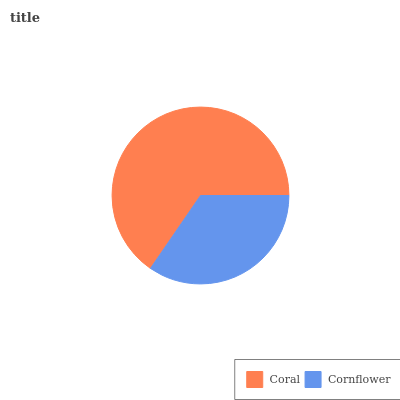Is Cornflower the minimum?
Answer yes or no. Yes. Is Coral the maximum?
Answer yes or no. Yes. Is Cornflower the maximum?
Answer yes or no. No. Is Coral greater than Cornflower?
Answer yes or no. Yes. Is Cornflower less than Coral?
Answer yes or no. Yes. Is Cornflower greater than Coral?
Answer yes or no. No. Is Coral less than Cornflower?
Answer yes or no. No. Is Coral the high median?
Answer yes or no. Yes. Is Cornflower the low median?
Answer yes or no. Yes. Is Cornflower the high median?
Answer yes or no. No. Is Coral the low median?
Answer yes or no. No. 